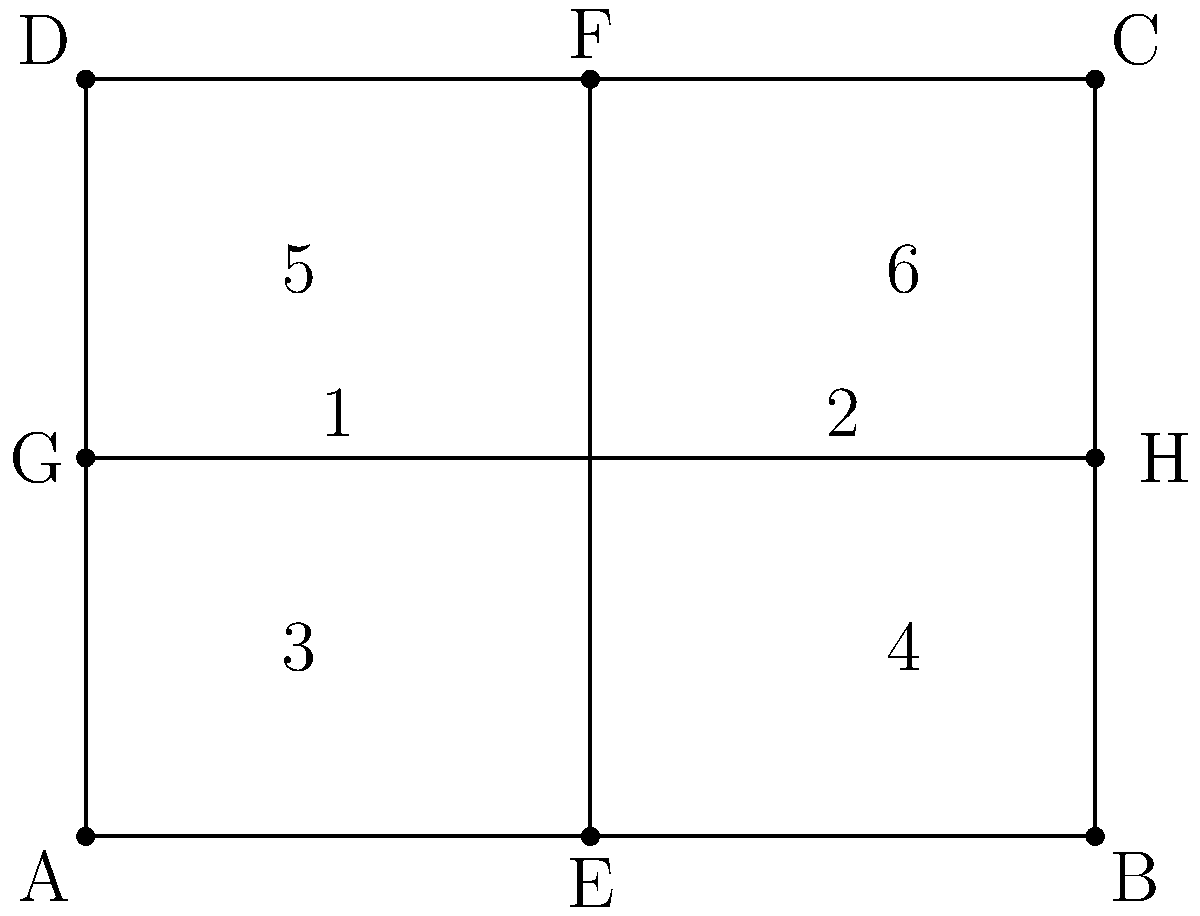In the diagram above, ABCD represents a wooden cabinet door. The door is divided into six sections by lines EF and GH. If you were to place handles in sections 1 and 6, would the resulting design be congruent to a design with handles in sections 3 and 4? Explain your reasoning. To determine if the two handle placements would result in congruent designs, we need to follow these steps:

1. Understand congruence: Two geometric figures are congruent if they have the same shape and size, meaning one can be transformed into the other through rigid motions (translations, rotations, or reflections).

2. Analyze the door sections:
   - Sections 1 and 6 are diagonally opposite.
   - Sections 3 and 4 are horizontally adjacent in the bottom half.

3. Consider potential transformations:
   - There is no single rotation or translation that can map sections 1 and 6 onto 3 and 4.
   - A reflection across the horizontal line GH would map section 1 onto section 3, but it would also map section 6 onto section 5, not section 4.

4. Examine the spatial relationships:
   - The distance between sections 1 and 6 is greater than the distance between sections 3 and 4.
   - The angle formed by lines connecting the centers of sections 1 and 6 to the door's center is different from the angle formed by lines connecting the centers of sections 3 and 4.

5. Conclusion:
   Since there is no combination of rigid motions that can transform the design with handles in sections 1 and 6 into a design with handles in sections 3 and 4 while preserving all spatial relationships, the two designs are not congruent.
Answer: No, not congruent 